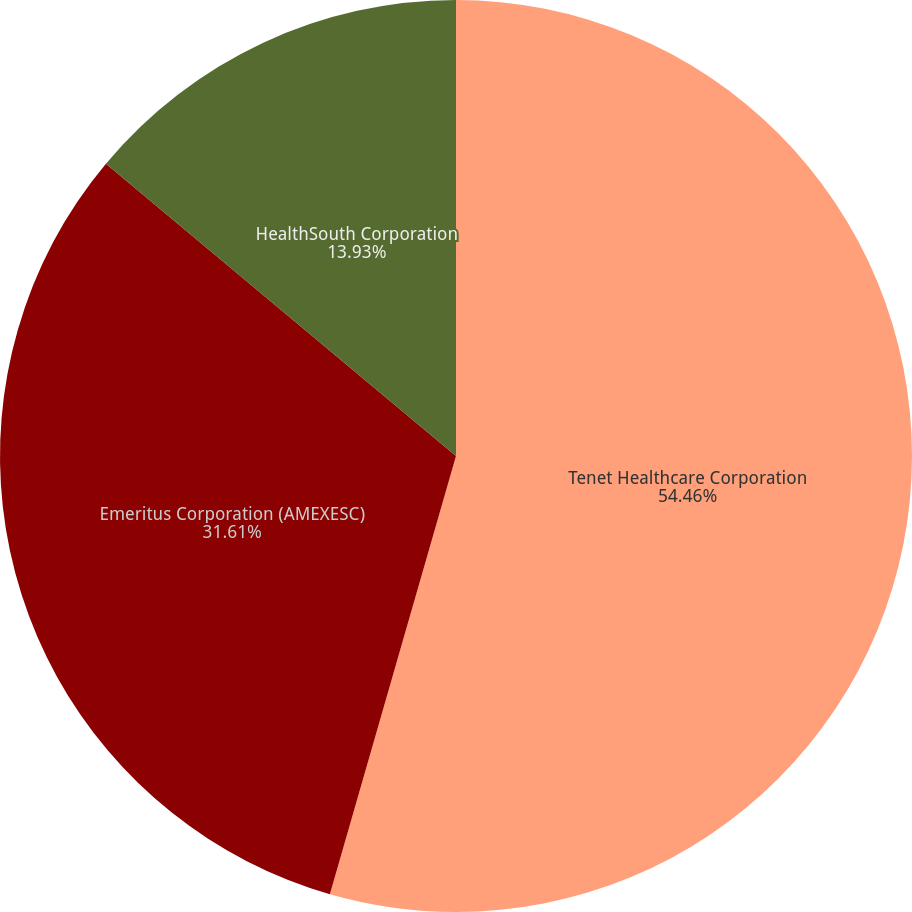Convert chart. <chart><loc_0><loc_0><loc_500><loc_500><pie_chart><fcel>Tenet Healthcare Corporation<fcel>Emeritus Corporation (AMEXESC)<fcel>HealthSouth Corporation<nl><fcel>54.46%<fcel>31.61%<fcel>13.93%<nl></chart> 